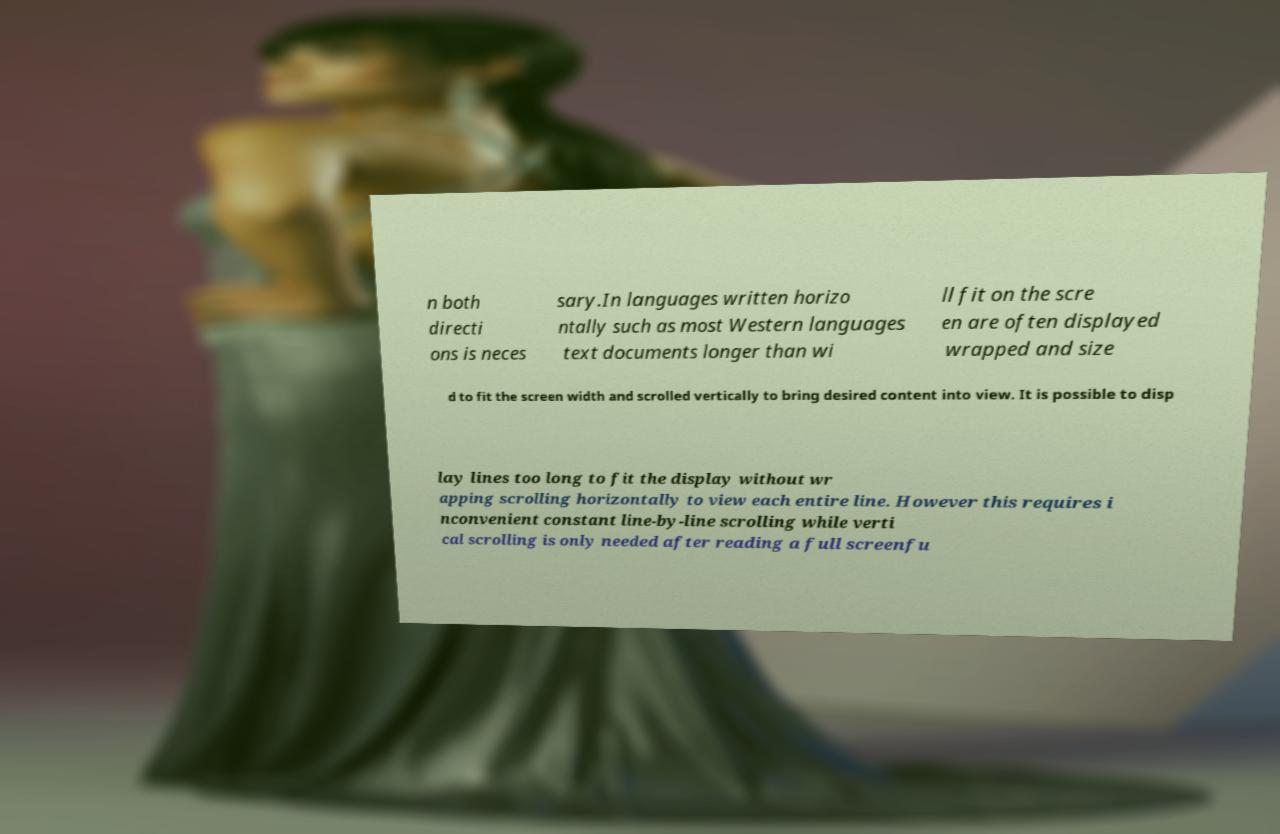Could you extract and type out the text from this image? n both directi ons is neces sary.In languages written horizo ntally such as most Western languages text documents longer than wi ll fit on the scre en are often displayed wrapped and size d to fit the screen width and scrolled vertically to bring desired content into view. It is possible to disp lay lines too long to fit the display without wr apping scrolling horizontally to view each entire line. However this requires i nconvenient constant line-by-line scrolling while verti cal scrolling is only needed after reading a full screenfu 